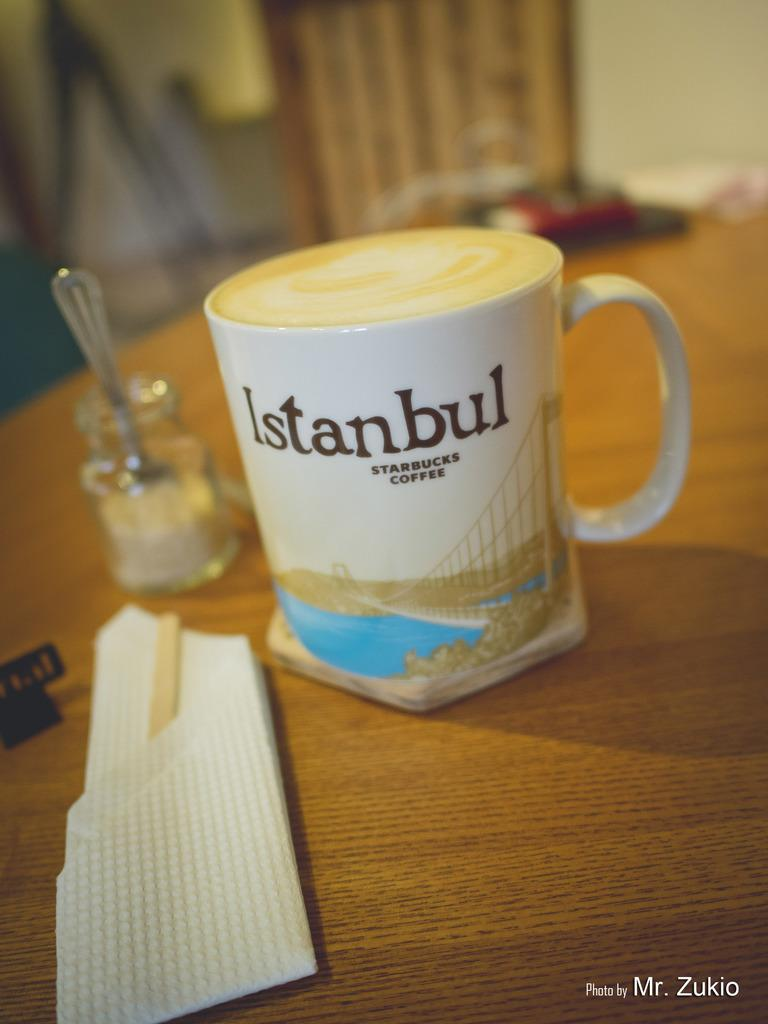<image>
Relay a brief, clear account of the picture shown. A starbucks coffee cup with the word Istanbul on it. 